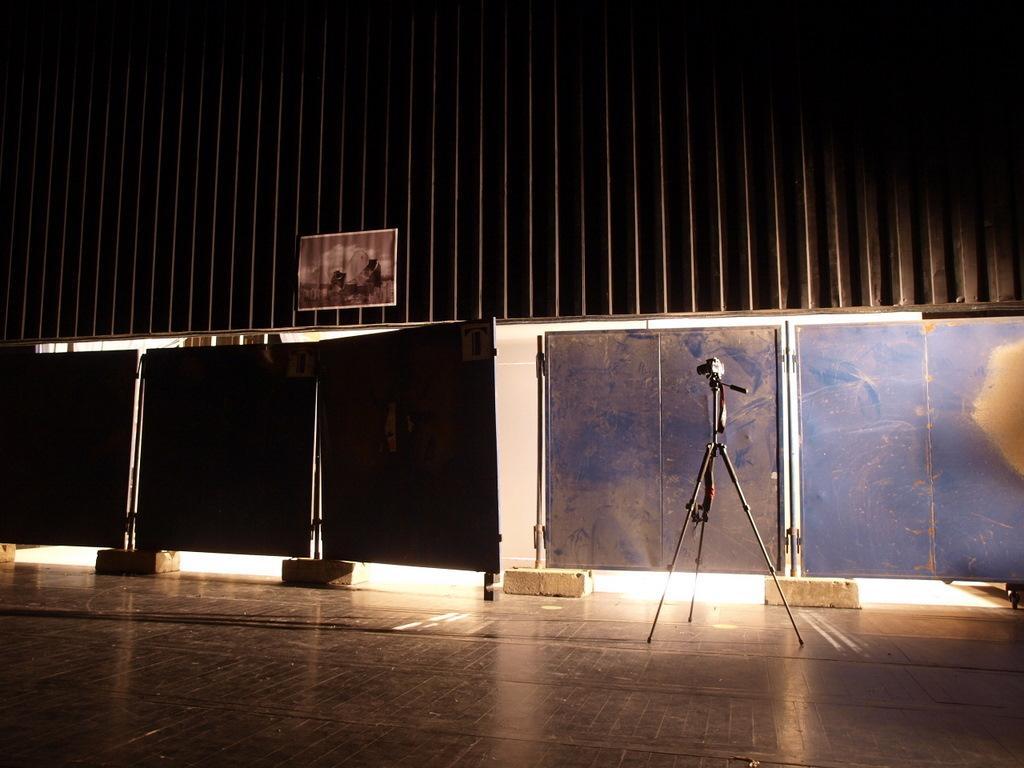Describe this image in one or two sentences. In this picture it looks like a hall and I can see a poster and few metal sheets and I can see a video camera to the stand. 